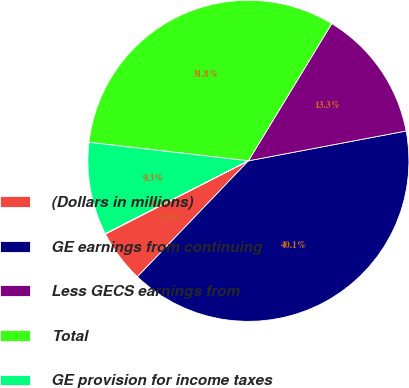Convert chart. <chart><loc_0><loc_0><loc_500><loc_500><pie_chart><fcel>(Dollars in millions)<fcel>GE earnings from continuing<fcel>Less GECS earnings from<fcel>Total<fcel>GE provision for income taxes<fcel>GE effective tax rate<nl><fcel>5.32%<fcel>40.13%<fcel>13.34%<fcel>31.85%<fcel>9.33%<fcel>0.04%<nl></chart> 